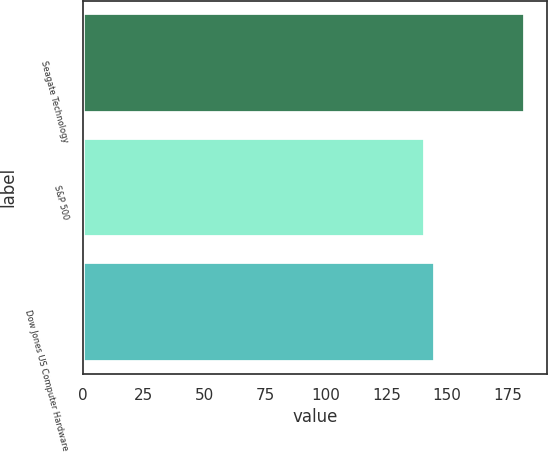Convert chart to OTSL. <chart><loc_0><loc_0><loc_500><loc_500><bar_chart><fcel>Seagate Technology<fcel>S&P 500<fcel>Dow Jones US Computer Hardware<nl><fcel>181.98<fcel>140.9<fcel>145.01<nl></chart> 